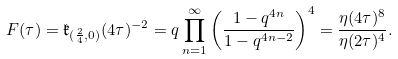<formula> <loc_0><loc_0><loc_500><loc_500>F ( \tau ) = \mathfrak { k } _ { ( \frac { 2 } { 4 } , 0 ) } ( 4 \tau ) ^ { - 2 } = q \prod _ { n = 1 } ^ { \infty } \left ( \frac { 1 - q ^ { 4 n } } { 1 - q ^ { 4 n - 2 } } \right ) ^ { 4 } = \frac { \eta ( 4 \tau ) ^ { 8 } } { \eta ( 2 \tau ) ^ { 4 } } .</formula> 